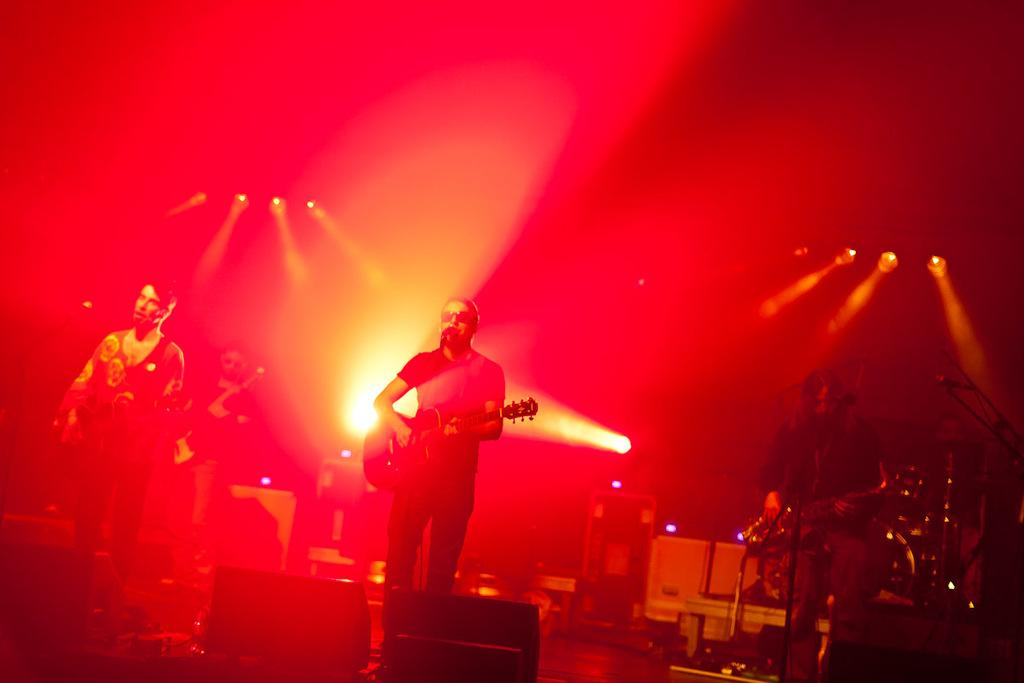How many people are in the image? There are three people in the image. What are the people doing in the image? The people are standing and playing musical instruments. Can you describe the background of the image? There are lights visible in the background of the image. What type of lettuce can be seen in the image? There is no lettuce present in the image. What order are the people following while playing their instruments? The provided facts do not mention any specific order in which the people are playing their instruments. 